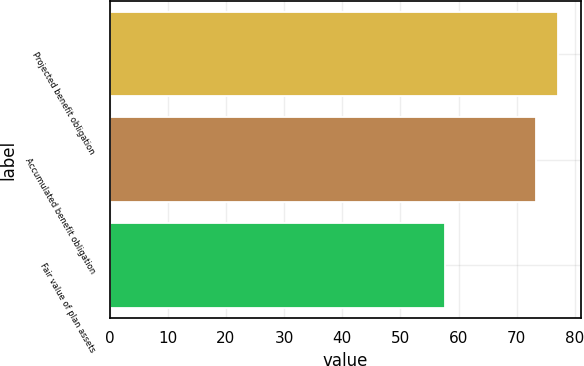Convert chart. <chart><loc_0><loc_0><loc_500><loc_500><bar_chart><fcel>Projected benefit obligation<fcel>Accumulated benefit obligation<fcel>Fair value of plan assets<nl><fcel>77.1<fcel>73.3<fcel>57.6<nl></chart> 